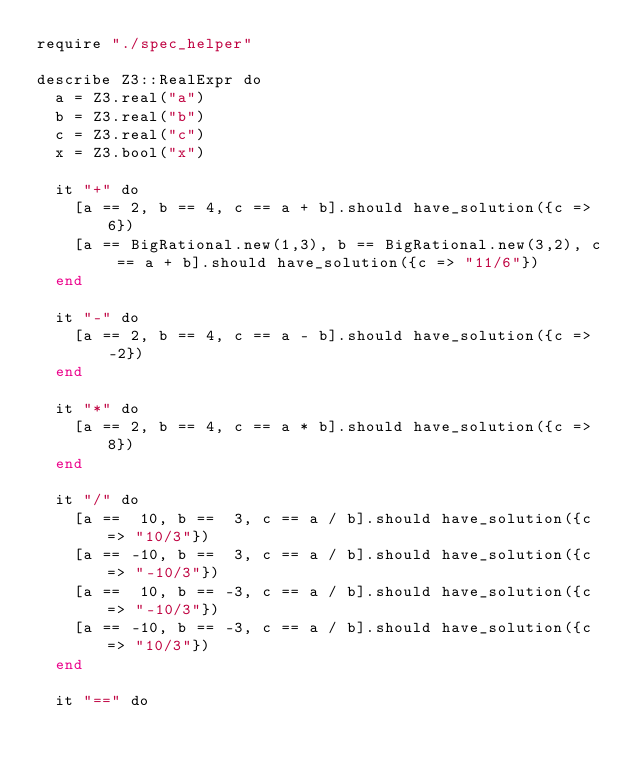Convert code to text. <code><loc_0><loc_0><loc_500><loc_500><_Crystal_>require "./spec_helper"

describe Z3::RealExpr do
  a = Z3.real("a")
  b = Z3.real("b")
  c = Z3.real("c")
  x = Z3.bool("x")

  it "+" do
    [a == 2, b == 4, c == a + b].should have_solution({c => 6})
    [a == BigRational.new(1,3), b == BigRational.new(3,2), c == a + b].should have_solution({c => "11/6"})
  end

  it "-" do
    [a == 2, b == 4, c == a - b].should have_solution({c => -2})
  end

  it "*" do
    [a == 2, b == 4, c == a * b].should have_solution({c => 8})
  end

  it "/" do
    [a ==  10, b ==  3, c == a / b].should have_solution({c => "10/3"})
    [a == -10, b ==  3, c == a / b].should have_solution({c => "-10/3"})
    [a ==  10, b == -3, c == a / b].should have_solution({c => "-10/3"})
    [a == -10, b == -3, c == a / b].should have_solution({c => "10/3"})
  end

  it "==" do</code> 